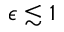<formula> <loc_0><loc_0><loc_500><loc_500>\epsilon \lesssim 1</formula> 